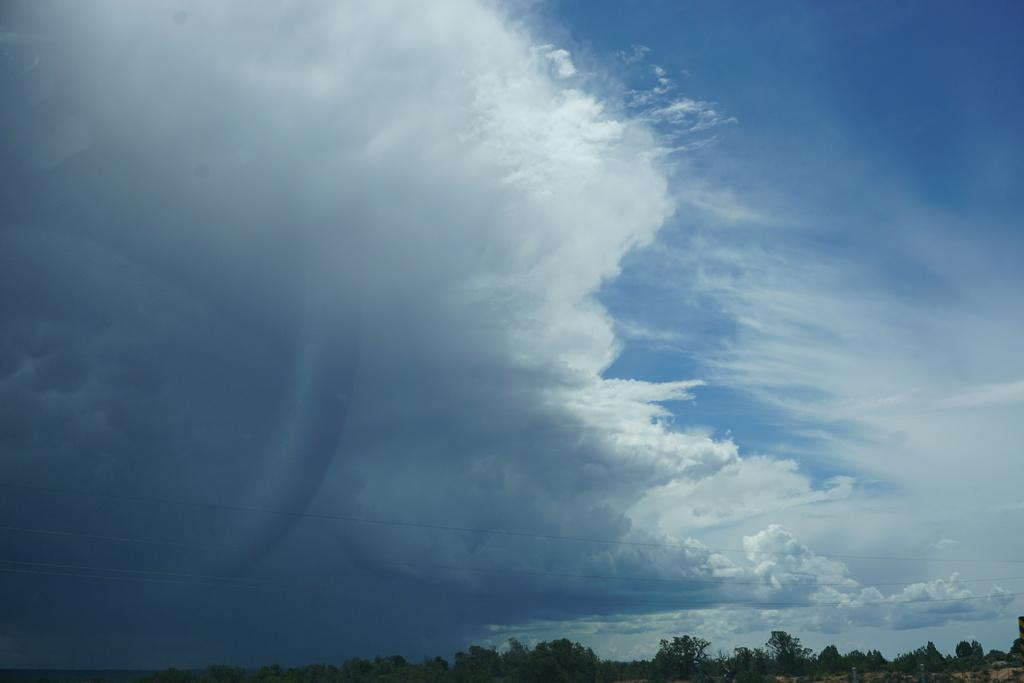What type of vegetation is at the bottom of the image? There are trees at the bottom of the image. What part of the natural environment is visible in the image? The sky is visible in the center of the image. What type of humor can be seen in the image? There is no humor present in the image; it features trees at the bottom and the sky in the center. Can you tell me how many firemen are visible in the image? There are no firemen present in the image. 